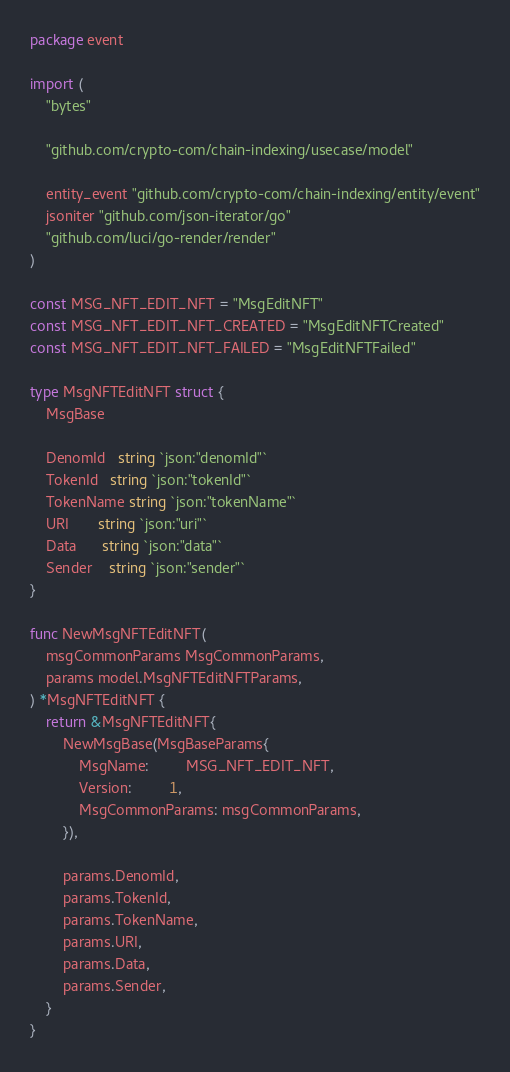Convert code to text. <code><loc_0><loc_0><loc_500><loc_500><_Go_>package event

import (
	"bytes"

	"github.com/crypto-com/chain-indexing/usecase/model"

	entity_event "github.com/crypto-com/chain-indexing/entity/event"
	jsoniter "github.com/json-iterator/go"
	"github.com/luci/go-render/render"
)

const MSG_NFT_EDIT_NFT = "MsgEditNFT"
const MSG_NFT_EDIT_NFT_CREATED = "MsgEditNFTCreated"
const MSG_NFT_EDIT_NFT_FAILED = "MsgEditNFTFailed"

type MsgNFTEditNFT struct {
	MsgBase

	DenomId   string `json:"denomId"`
	TokenId   string `json:"tokenId"`
	TokenName string `json:"tokenName"`
	URI       string `json:"uri"`
	Data      string `json:"data"`
	Sender    string `json:"sender"`
}

func NewMsgNFTEditNFT(
	msgCommonParams MsgCommonParams,
	params model.MsgNFTEditNFTParams,
) *MsgNFTEditNFT {
	return &MsgNFTEditNFT{
		NewMsgBase(MsgBaseParams{
			MsgName:         MSG_NFT_EDIT_NFT,
			Version:         1,
			MsgCommonParams: msgCommonParams,
		}),

		params.DenomId,
		params.TokenId,
		params.TokenName,
		params.URI,
		params.Data,
		params.Sender,
	}
}
</code> 